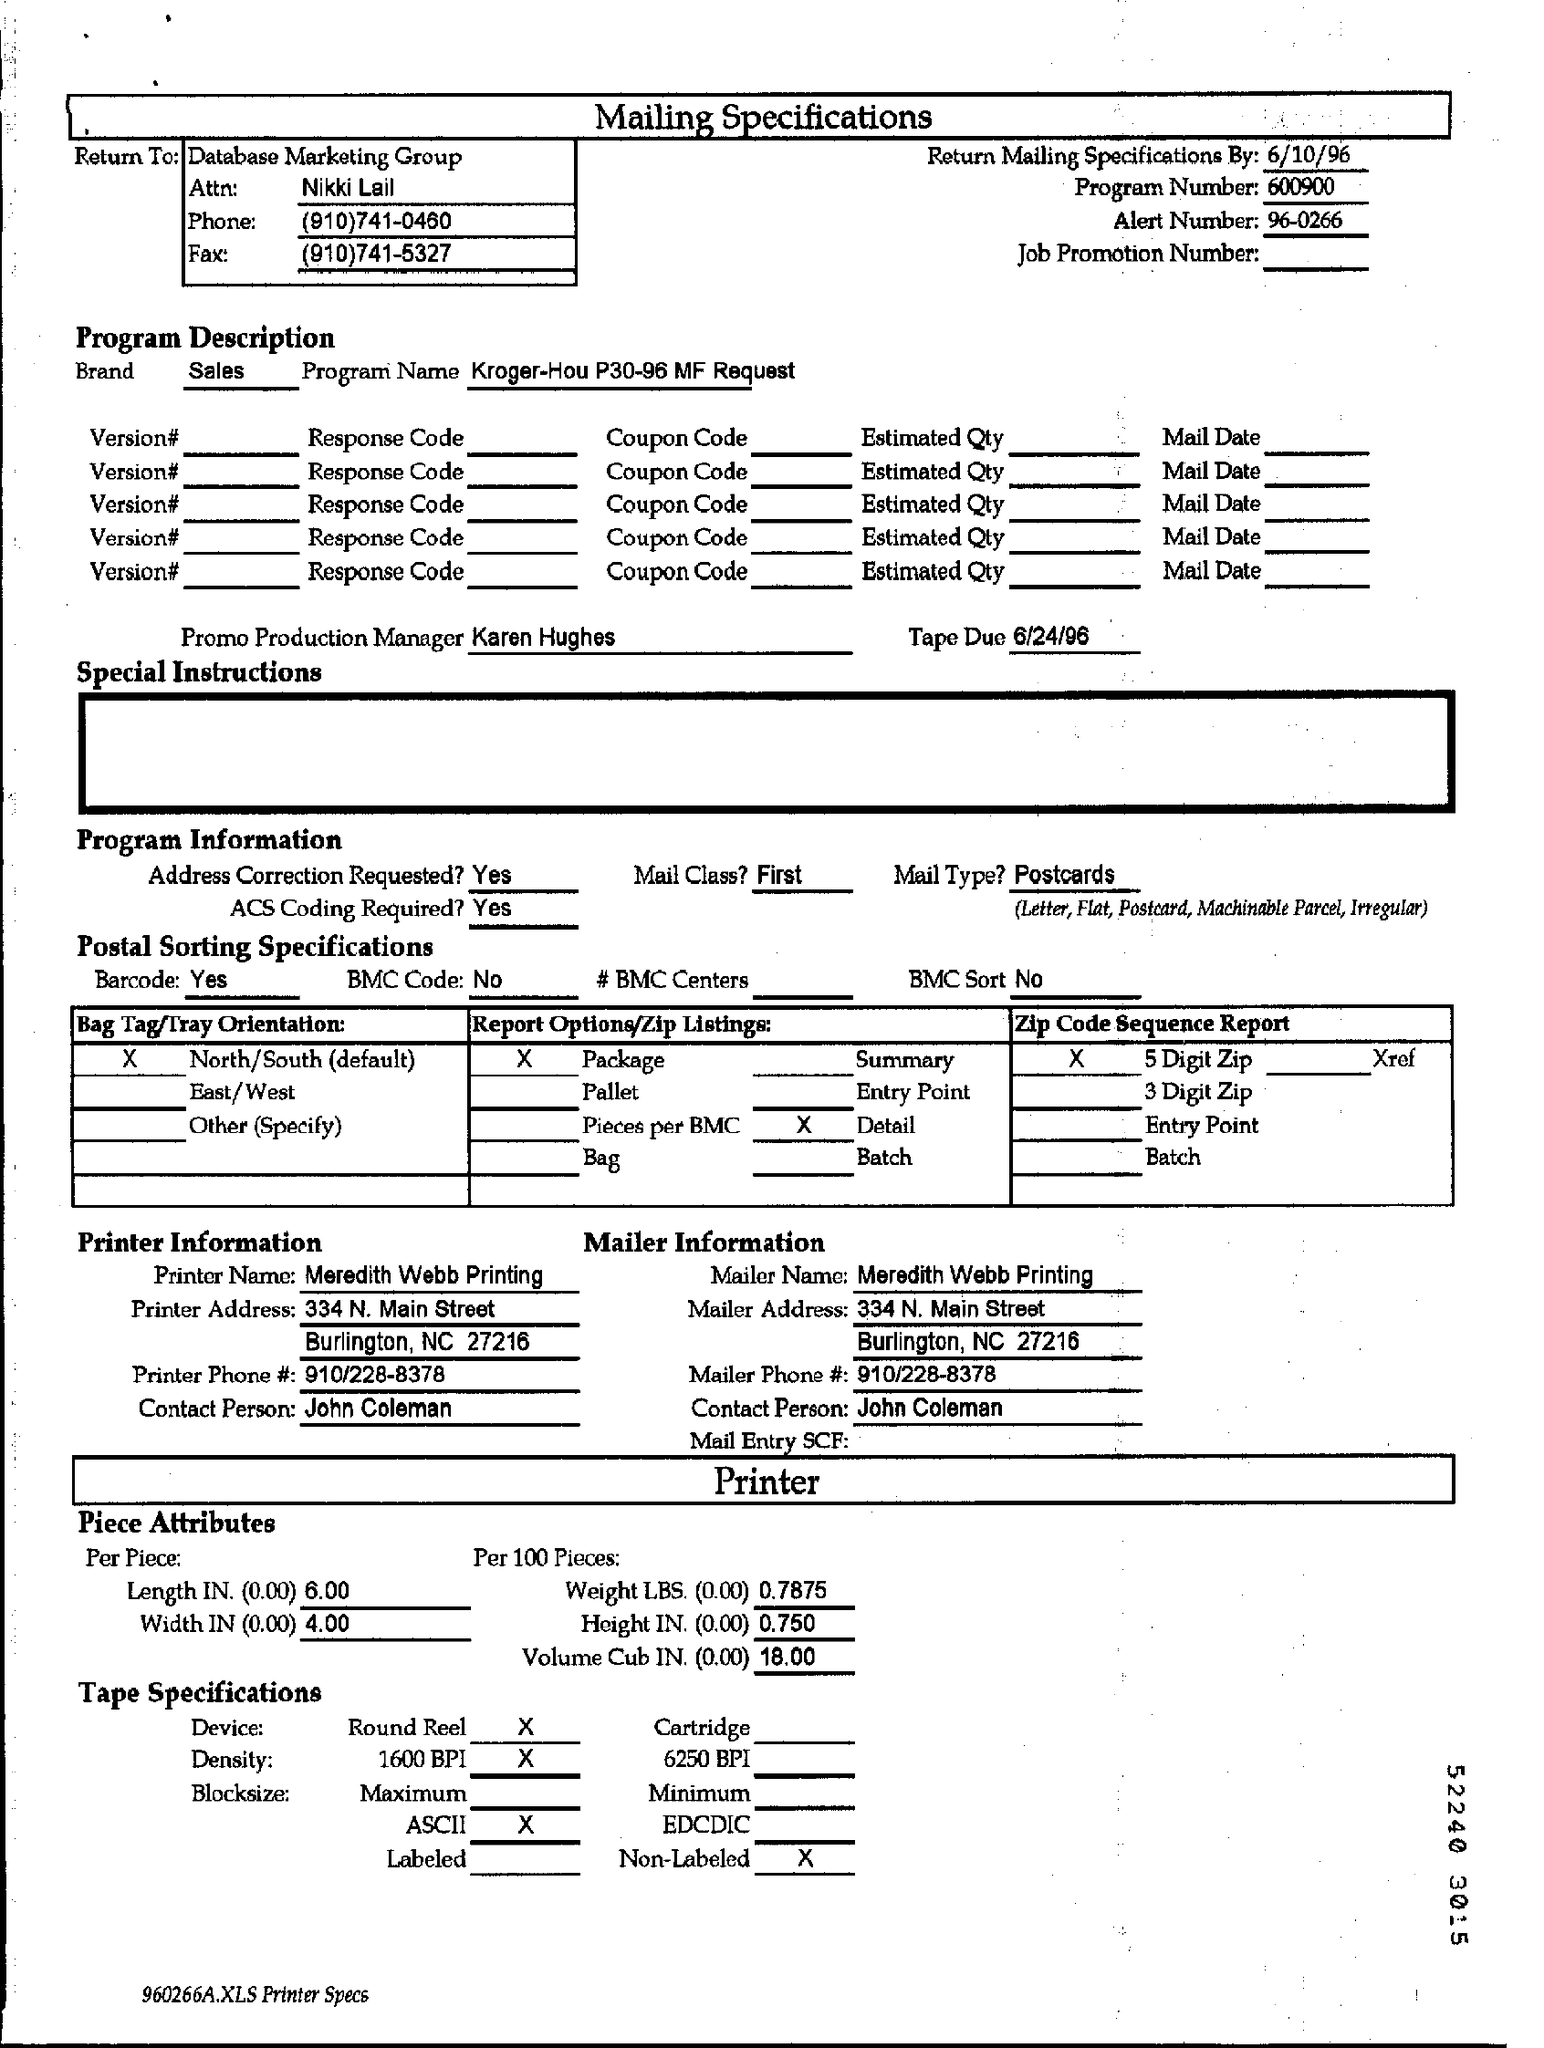Point out several critical features in this image. The promotional production manager is Karen Hughes. The phone number of Data Base Marketing Group is (910)741-0460. The program called Number consists of 600900 consecutive digits. The name of Attn is Nikki Lail. For the printer information, the contact person is John Coleman. 